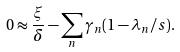Convert formula to latex. <formula><loc_0><loc_0><loc_500><loc_500>0 \approx \frac { \xi } { \delta } - \sum _ { n } \gamma _ { n } ( 1 - \lambda _ { n } / s ) .</formula> 